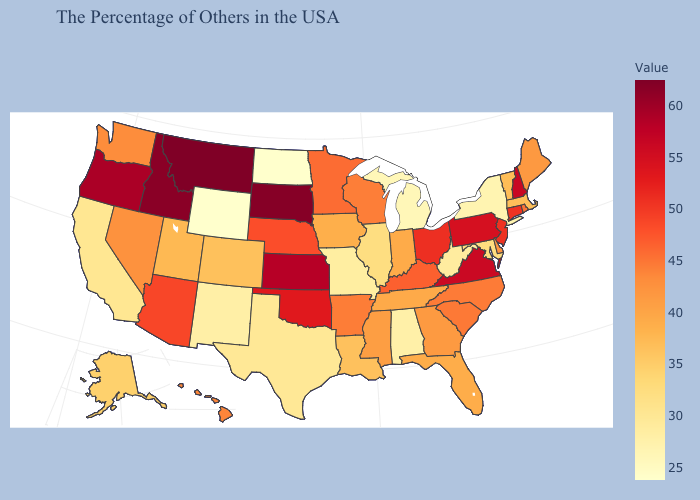Does Montana have a lower value than Arizona?
Concise answer only. No. Which states have the lowest value in the West?
Give a very brief answer. Wyoming. Among the states that border Maryland , which have the highest value?
Keep it brief. Virginia. Does the map have missing data?
Keep it brief. No. Does Illinois have a lower value than Michigan?
Write a very short answer. No. Does Wisconsin have a lower value than Utah?
Short answer required. No. 